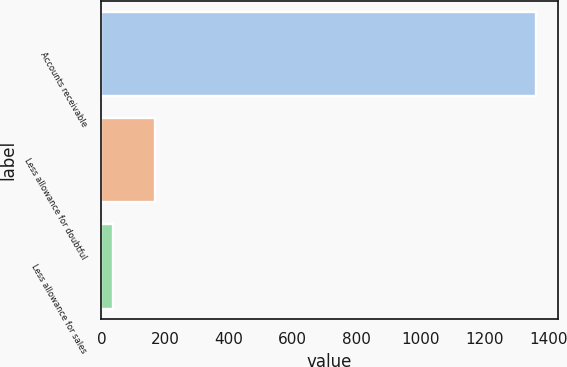Convert chart. <chart><loc_0><loc_0><loc_500><loc_500><bar_chart><fcel>Accounts receivable<fcel>Less allowance for doubtful<fcel>Less allowance for sales<nl><fcel>1362<fcel>167.7<fcel>35<nl></chart> 